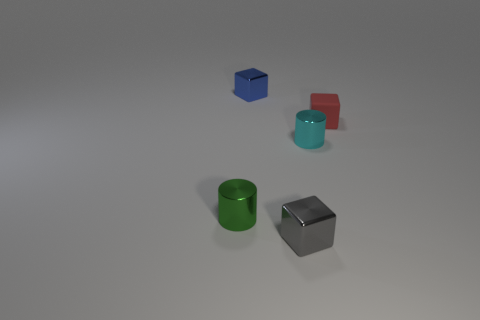Are there any other things that have the same material as the tiny red block?
Make the answer very short. No. Is the number of tiny objects behind the small gray shiny block greater than the number of blue objects in front of the rubber block?
Your answer should be very brief. Yes. Are there any brown metal spheres that have the same size as the gray cube?
Keep it short and to the point. No. What size is the metallic cylinder to the left of the small metal block in front of the small red thing that is behind the green metal object?
Make the answer very short. Small. What is the color of the tiny matte block?
Your response must be concise. Red. Are there more red objects to the left of the tiny cyan object than cylinders?
Your answer should be very brief. No. There is a tiny cyan thing; what number of green metallic things are in front of it?
Offer a very short reply. 1. Is there a small blue cube left of the tiny metallic block that is to the left of the small shiny object that is in front of the small green metal cylinder?
Offer a terse response. No. Is the size of the matte cube the same as the cyan metal cylinder?
Your answer should be very brief. Yes. Are there the same number of matte cubes that are on the left side of the small green cylinder and tiny gray objects that are to the right of the small gray shiny thing?
Your response must be concise. Yes. 